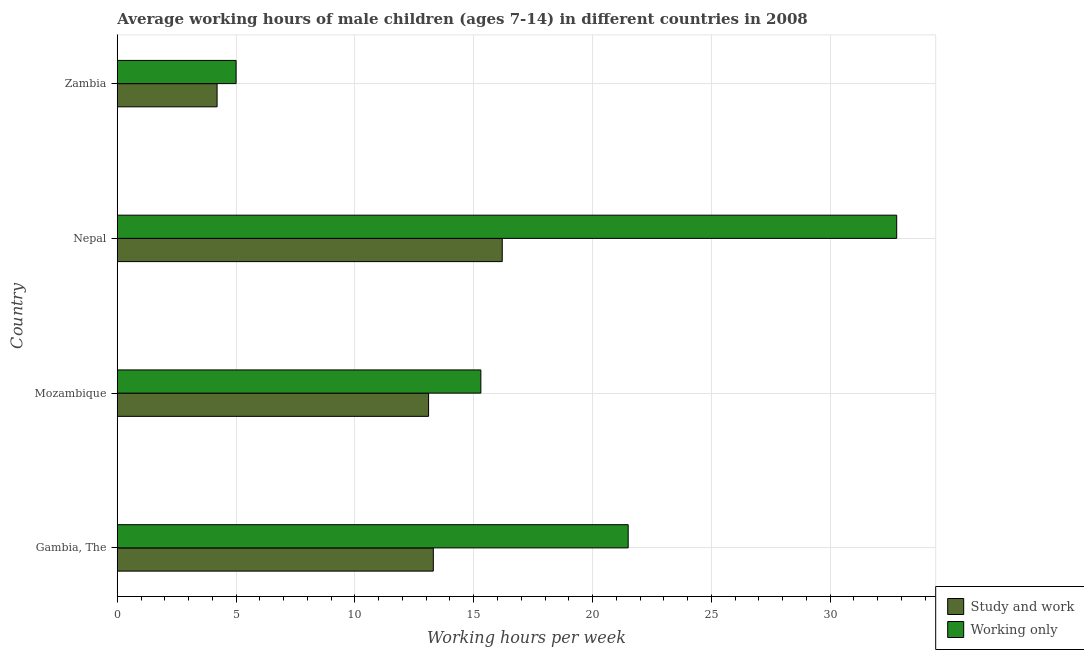How many groups of bars are there?
Keep it short and to the point. 4. Are the number of bars per tick equal to the number of legend labels?
Give a very brief answer. Yes. Are the number of bars on each tick of the Y-axis equal?
Ensure brevity in your answer.  Yes. How many bars are there on the 4th tick from the top?
Your answer should be compact. 2. How many bars are there on the 4th tick from the bottom?
Provide a short and direct response. 2. What is the label of the 4th group of bars from the top?
Provide a succinct answer. Gambia, The. In how many cases, is the number of bars for a given country not equal to the number of legend labels?
Ensure brevity in your answer.  0. Across all countries, what is the maximum average working hour of children involved in only work?
Your response must be concise. 32.8. Across all countries, what is the minimum average working hour of children involved in only work?
Your response must be concise. 5. In which country was the average working hour of children involved in only work maximum?
Your answer should be very brief. Nepal. In which country was the average working hour of children involved in study and work minimum?
Ensure brevity in your answer.  Zambia. What is the total average working hour of children involved in study and work in the graph?
Ensure brevity in your answer.  46.8. What is the difference between the average working hour of children involved in only work in Gambia, The and that in Zambia?
Your response must be concise. 16.5. What is the average average working hour of children involved in only work per country?
Offer a very short reply. 18.65. In how many countries, is the average working hour of children involved in only work greater than 16 hours?
Provide a short and direct response. 2. What is the ratio of the average working hour of children involved in study and work in Mozambique to that in Nepal?
Ensure brevity in your answer.  0.81. Is the difference between the average working hour of children involved in study and work in Mozambique and Zambia greater than the difference between the average working hour of children involved in only work in Mozambique and Zambia?
Your answer should be compact. No. What is the difference between the highest and the second highest average working hour of children involved in only work?
Your answer should be very brief. 11.3. What is the difference between the highest and the lowest average working hour of children involved in study and work?
Give a very brief answer. 12. In how many countries, is the average working hour of children involved in only work greater than the average average working hour of children involved in only work taken over all countries?
Your answer should be very brief. 2. What does the 1st bar from the top in Gambia, The represents?
Provide a short and direct response. Working only. What does the 2nd bar from the bottom in Nepal represents?
Keep it short and to the point. Working only. How many bars are there?
Make the answer very short. 8. Are all the bars in the graph horizontal?
Ensure brevity in your answer.  Yes. What is the difference between two consecutive major ticks on the X-axis?
Offer a terse response. 5. Are the values on the major ticks of X-axis written in scientific E-notation?
Make the answer very short. No. Does the graph contain grids?
Provide a succinct answer. Yes. Where does the legend appear in the graph?
Offer a terse response. Bottom right. How many legend labels are there?
Keep it short and to the point. 2. What is the title of the graph?
Make the answer very short. Average working hours of male children (ages 7-14) in different countries in 2008. What is the label or title of the X-axis?
Keep it short and to the point. Working hours per week. What is the Working hours per week of Study and work in Gambia, The?
Provide a succinct answer. 13.3. What is the Working hours per week in Working only in Nepal?
Keep it short and to the point. 32.8. What is the Working hours per week in Study and work in Zambia?
Make the answer very short. 4.2. Across all countries, what is the maximum Working hours per week in Working only?
Ensure brevity in your answer.  32.8. Across all countries, what is the minimum Working hours per week in Working only?
Your response must be concise. 5. What is the total Working hours per week of Study and work in the graph?
Offer a terse response. 46.8. What is the total Working hours per week of Working only in the graph?
Offer a terse response. 74.6. What is the difference between the Working hours per week of Working only in Gambia, The and that in Mozambique?
Give a very brief answer. 6.2. What is the difference between the Working hours per week of Working only in Gambia, The and that in Nepal?
Your answer should be compact. -11.3. What is the difference between the Working hours per week in Study and work in Gambia, The and that in Zambia?
Give a very brief answer. 9.1. What is the difference between the Working hours per week in Working only in Mozambique and that in Nepal?
Provide a short and direct response. -17.5. What is the difference between the Working hours per week in Working only in Mozambique and that in Zambia?
Provide a succinct answer. 10.3. What is the difference between the Working hours per week in Working only in Nepal and that in Zambia?
Make the answer very short. 27.8. What is the difference between the Working hours per week in Study and work in Gambia, The and the Working hours per week in Working only in Nepal?
Keep it short and to the point. -19.5. What is the difference between the Working hours per week in Study and work in Mozambique and the Working hours per week in Working only in Nepal?
Offer a very short reply. -19.7. What is the difference between the Working hours per week in Study and work in Nepal and the Working hours per week in Working only in Zambia?
Ensure brevity in your answer.  11.2. What is the average Working hours per week in Study and work per country?
Your answer should be compact. 11.7. What is the average Working hours per week of Working only per country?
Your response must be concise. 18.65. What is the difference between the Working hours per week in Study and work and Working hours per week in Working only in Mozambique?
Your response must be concise. -2.2. What is the difference between the Working hours per week of Study and work and Working hours per week of Working only in Nepal?
Your response must be concise. -16.6. What is the ratio of the Working hours per week of Study and work in Gambia, The to that in Mozambique?
Make the answer very short. 1.02. What is the ratio of the Working hours per week of Working only in Gambia, The to that in Mozambique?
Offer a terse response. 1.41. What is the ratio of the Working hours per week of Study and work in Gambia, The to that in Nepal?
Offer a very short reply. 0.82. What is the ratio of the Working hours per week of Working only in Gambia, The to that in Nepal?
Provide a succinct answer. 0.66. What is the ratio of the Working hours per week of Study and work in Gambia, The to that in Zambia?
Provide a succinct answer. 3.17. What is the ratio of the Working hours per week of Working only in Gambia, The to that in Zambia?
Provide a short and direct response. 4.3. What is the ratio of the Working hours per week in Study and work in Mozambique to that in Nepal?
Give a very brief answer. 0.81. What is the ratio of the Working hours per week of Working only in Mozambique to that in Nepal?
Make the answer very short. 0.47. What is the ratio of the Working hours per week of Study and work in Mozambique to that in Zambia?
Give a very brief answer. 3.12. What is the ratio of the Working hours per week of Working only in Mozambique to that in Zambia?
Offer a terse response. 3.06. What is the ratio of the Working hours per week of Study and work in Nepal to that in Zambia?
Offer a terse response. 3.86. What is the ratio of the Working hours per week of Working only in Nepal to that in Zambia?
Make the answer very short. 6.56. What is the difference between the highest and the second highest Working hours per week in Study and work?
Offer a terse response. 2.9. What is the difference between the highest and the lowest Working hours per week of Working only?
Provide a succinct answer. 27.8. 